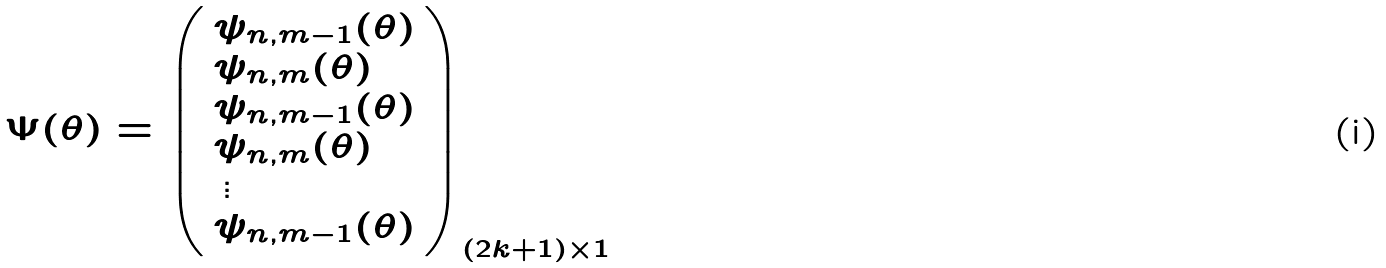Convert formula to latex. <formula><loc_0><loc_0><loc_500><loc_500>\Psi ( \theta ) = \left ( \begin{array} { l r } \psi _ { n , m - 1 } ( \theta ) \\ \psi _ { n , m } ( \theta ) \\ \psi _ { n , m - 1 } ( \theta ) \\ \psi _ { n , m } ( \theta ) \\ \, \vdots \\ \psi _ { n , m - 1 } ( \theta ) \\ \end{array} \right ) _ { ( 2 k + 1 ) \times 1 }</formula> 